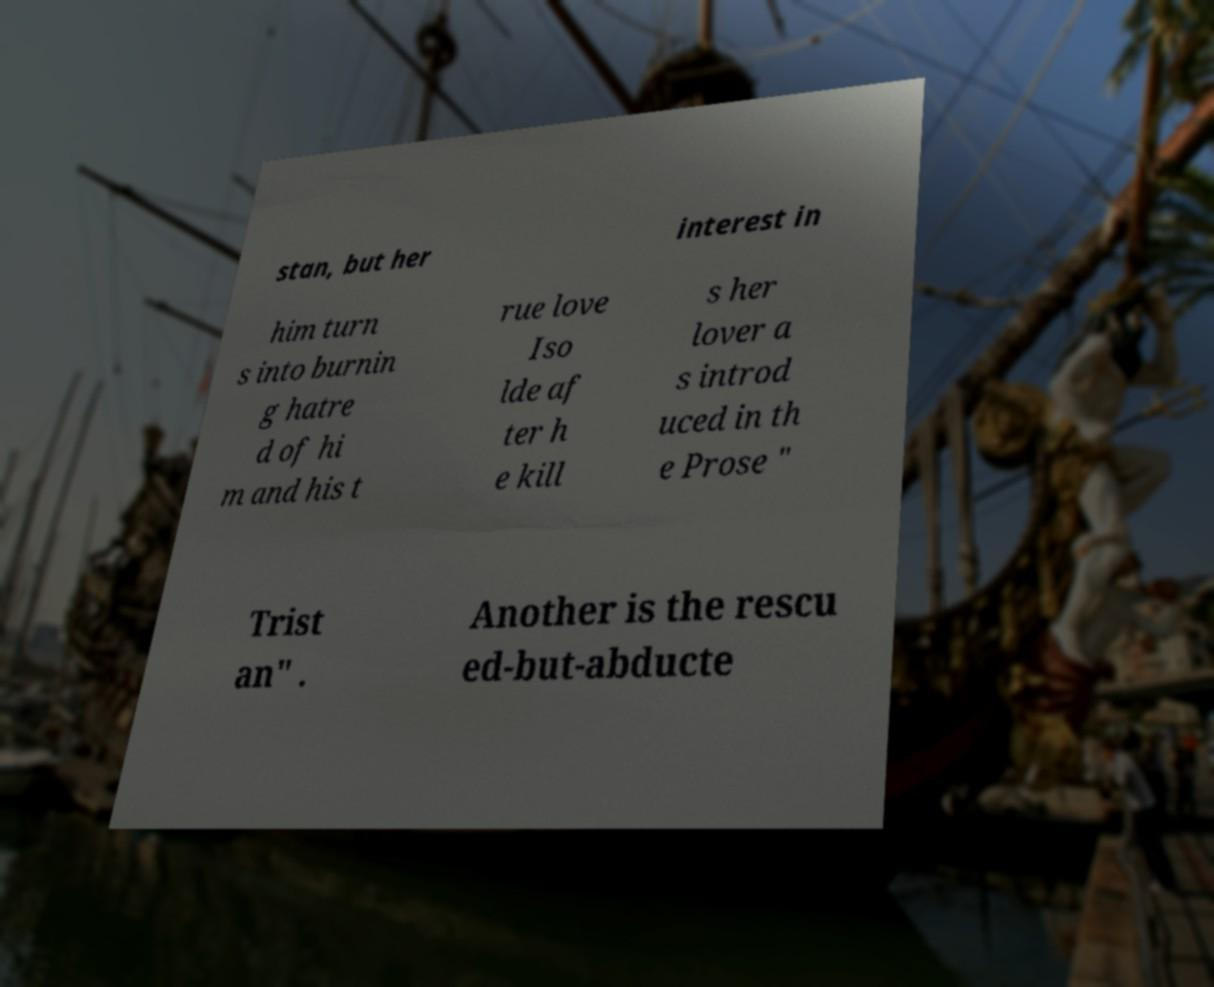Please identify and transcribe the text found in this image. stan, but her interest in him turn s into burnin g hatre d of hi m and his t rue love Iso lde af ter h e kill s her lover a s introd uced in th e Prose " Trist an" . Another is the rescu ed-but-abducte 